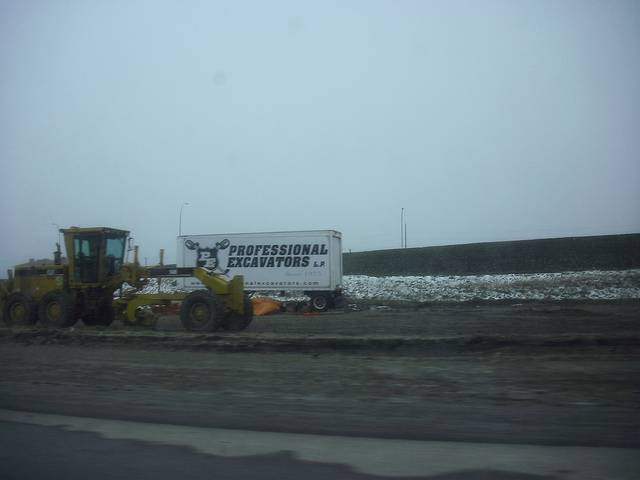Please transcribe the text information in this image. PROFESSIONAL EXCAVATORS 